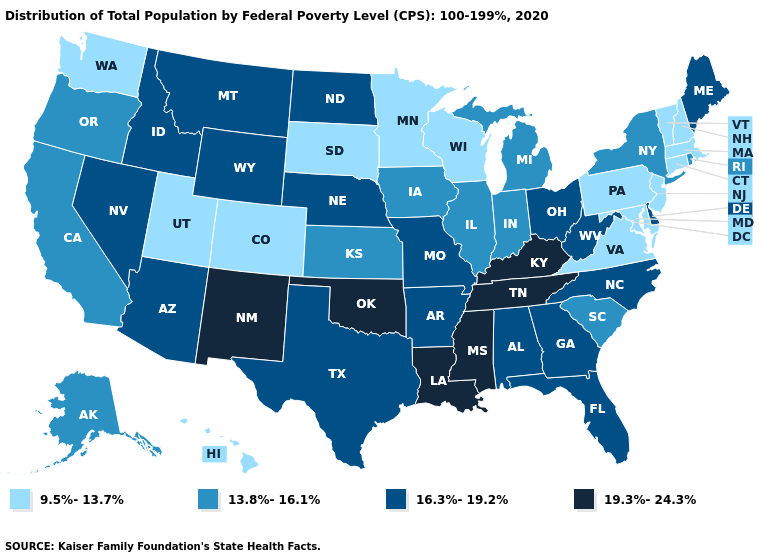Which states have the lowest value in the MidWest?
Give a very brief answer. Minnesota, South Dakota, Wisconsin. What is the value of Maine?
Quick response, please. 16.3%-19.2%. Among the states that border Pennsylvania , does Delaware have the highest value?
Answer briefly. Yes. Among the states that border Pennsylvania , which have the lowest value?
Be succinct. Maryland, New Jersey. Name the states that have a value in the range 16.3%-19.2%?
Keep it brief. Alabama, Arizona, Arkansas, Delaware, Florida, Georgia, Idaho, Maine, Missouri, Montana, Nebraska, Nevada, North Carolina, North Dakota, Ohio, Texas, West Virginia, Wyoming. Does Idaho have the lowest value in the USA?
Quick response, please. No. What is the value of Idaho?
Write a very short answer. 16.3%-19.2%. Which states have the lowest value in the Northeast?
Answer briefly. Connecticut, Massachusetts, New Hampshire, New Jersey, Pennsylvania, Vermont. Does Massachusetts have the highest value in the Northeast?
Be succinct. No. What is the value of Nebraska?
Answer briefly. 16.3%-19.2%. Does Arizona have a lower value than New Mexico?
Quick response, please. Yes. Which states have the lowest value in the South?
Answer briefly. Maryland, Virginia. Name the states that have a value in the range 13.8%-16.1%?
Quick response, please. Alaska, California, Illinois, Indiana, Iowa, Kansas, Michigan, New York, Oregon, Rhode Island, South Carolina. Name the states that have a value in the range 9.5%-13.7%?
Quick response, please. Colorado, Connecticut, Hawaii, Maryland, Massachusetts, Minnesota, New Hampshire, New Jersey, Pennsylvania, South Dakota, Utah, Vermont, Virginia, Washington, Wisconsin. Among the states that border Alabama , does Mississippi have the highest value?
Answer briefly. Yes. 